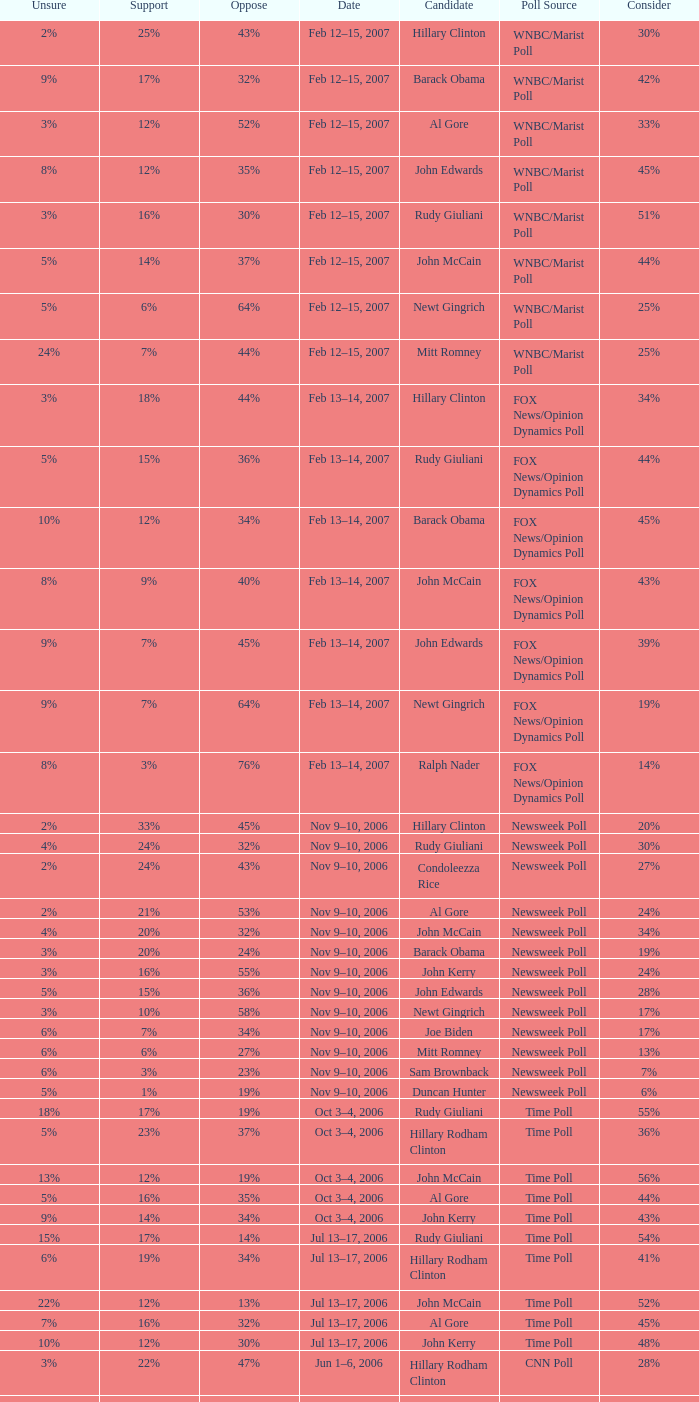What percentage of people were opposed to the candidate based on the WNBC/Marist poll that showed 8% of people were unsure? 35%. 